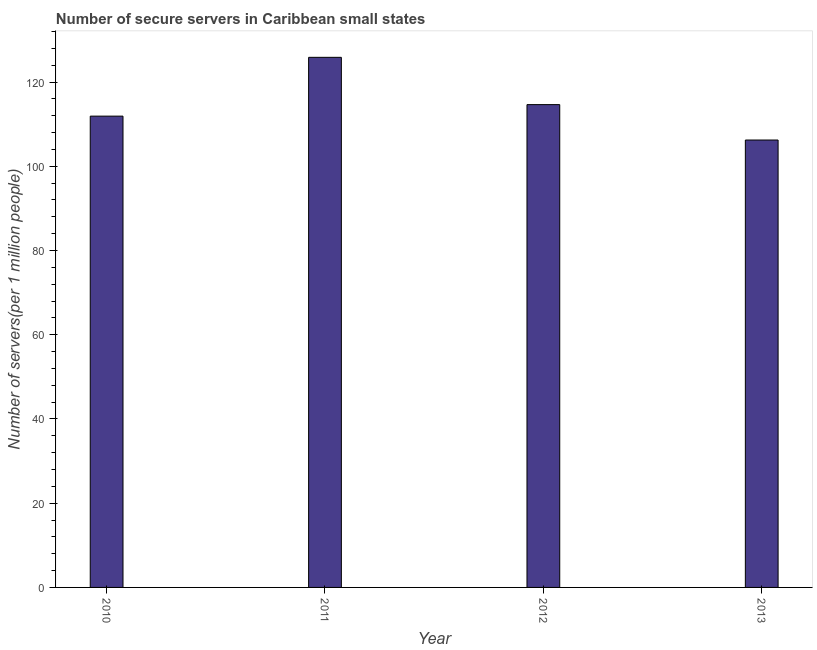Does the graph contain grids?
Offer a terse response. No. What is the title of the graph?
Your answer should be compact. Number of secure servers in Caribbean small states. What is the label or title of the Y-axis?
Your answer should be very brief. Number of servers(per 1 million people). What is the number of secure internet servers in 2013?
Ensure brevity in your answer.  106.22. Across all years, what is the maximum number of secure internet servers?
Make the answer very short. 125.86. Across all years, what is the minimum number of secure internet servers?
Your answer should be compact. 106.22. What is the sum of the number of secure internet servers?
Offer a terse response. 458.61. What is the difference between the number of secure internet servers in 2011 and 2012?
Provide a succinct answer. 11.23. What is the average number of secure internet servers per year?
Keep it short and to the point. 114.65. What is the median number of secure internet servers?
Your answer should be compact. 113.26. In how many years, is the number of secure internet servers greater than 100 ?
Give a very brief answer. 4. What is the ratio of the number of secure internet servers in 2012 to that in 2013?
Make the answer very short. 1.08. What is the difference between the highest and the second highest number of secure internet servers?
Your response must be concise. 11.23. Is the sum of the number of secure internet servers in 2011 and 2013 greater than the maximum number of secure internet servers across all years?
Provide a succinct answer. Yes. What is the difference between the highest and the lowest number of secure internet servers?
Give a very brief answer. 19.63. How many years are there in the graph?
Keep it short and to the point. 4. What is the difference between two consecutive major ticks on the Y-axis?
Ensure brevity in your answer.  20. What is the Number of servers(per 1 million people) of 2010?
Your answer should be compact. 111.9. What is the Number of servers(per 1 million people) of 2011?
Offer a very short reply. 125.86. What is the Number of servers(per 1 million people) of 2012?
Give a very brief answer. 114.63. What is the Number of servers(per 1 million people) in 2013?
Your answer should be compact. 106.22. What is the difference between the Number of servers(per 1 million people) in 2010 and 2011?
Your answer should be compact. -13.96. What is the difference between the Number of servers(per 1 million people) in 2010 and 2012?
Provide a succinct answer. -2.74. What is the difference between the Number of servers(per 1 million people) in 2010 and 2013?
Ensure brevity in your answer.  5.67. What is the difference between the Number of servers(per 1 million people) in 2011 and 2012?
Offer a very short reply. 11.23. What is the difference between the Number of servers(per 1 million people) in 2011 and 2013?
Make the answer very short. 19.63. What is the difference between the Number of servers(per 1 million people) in 2012 and 2013?
Provide a short and direct response. 8.41. What is the ratio of the Number of servers(per 1 million people) in 2010 to that in 2011?
Give a very brief answer. 0.89. What is the ratio of the Number of servers(per 1 million people) in 2010 to that in 2013?
Provide a short and direct response. 1.05. What is the ratio of the Number of servers(per 1 million people) in 2011 to that in 2012?
Keep it short and to the point. 1.1. What is the ratio of the Number of servers(per 1 million people) in 2011 to that in 2013?
Provide a short and direct response. 1.19. What is the ratio of the Number of servers(per 1 million people) in 2012 to that in 2013?
Your answer should be very brief. 1.08. 